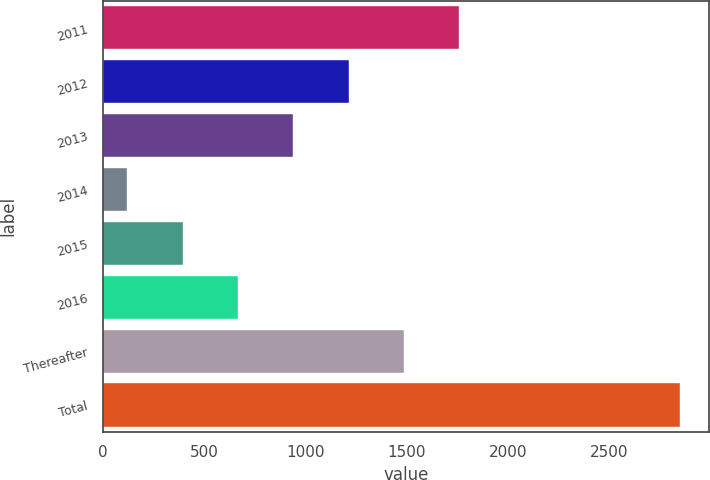<chart> <loc_0><loc_0><loc_500><loc_500><bar_chart><fcel>2011<fcel>2012<fcel>2013<fcel>2014<fcel>2015<fcel>2016<fcel>Thereafter<fcel>Total<nl><fcel>1760.6<fcel>1214.4<fcel>941.3<fcel>122<fcel>395.1<fcel>668.2<fcel>1487.5<fcel>2853<nl></chart> 